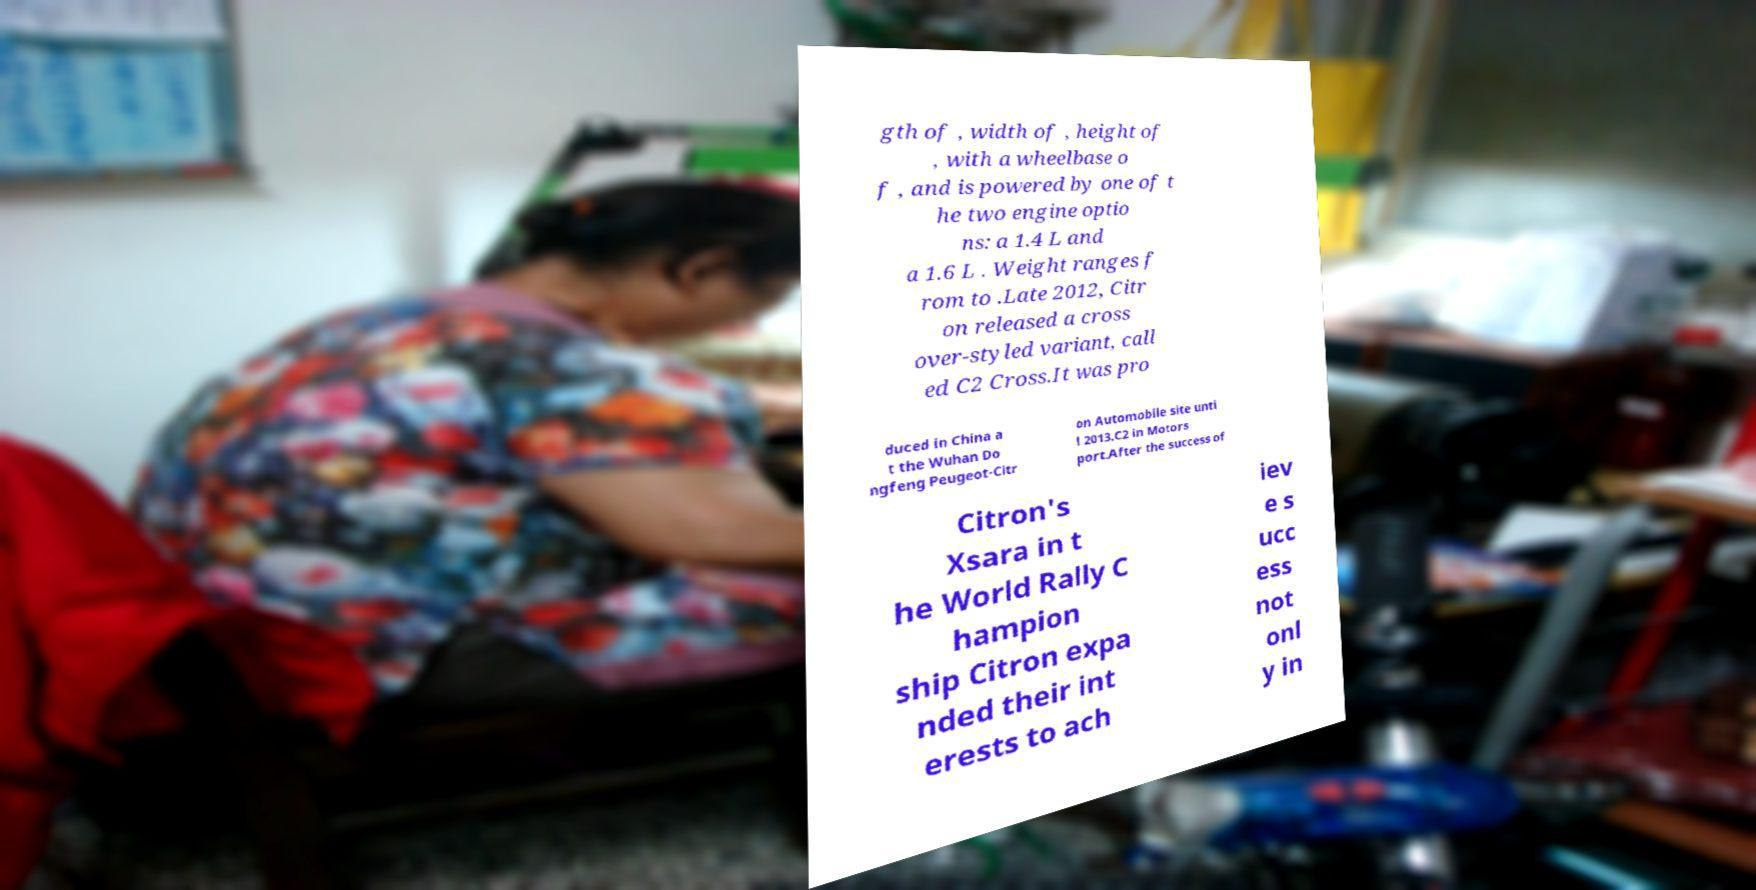Can you accurately transcribe the text from the provided image for me? gth of , width of , height of , with a wheelbase o f , and is powered by one of t he two engine optio ns: a 1.4 L and a 1.6 L . Weight ranges f rom to .Late 2012, Citr on released a cross over-styled variant, call ed C2 Cross.It was pro duced in China a t the Wuhan Do ngfeng Peugeot-Citr on Automobile site unti l 2013.C2 in Motors port.After the success of Citron's Xsara in t he World Rally C hampion ship Citron expa nded their int erests to ach iev e s ucc ess not onl y in 